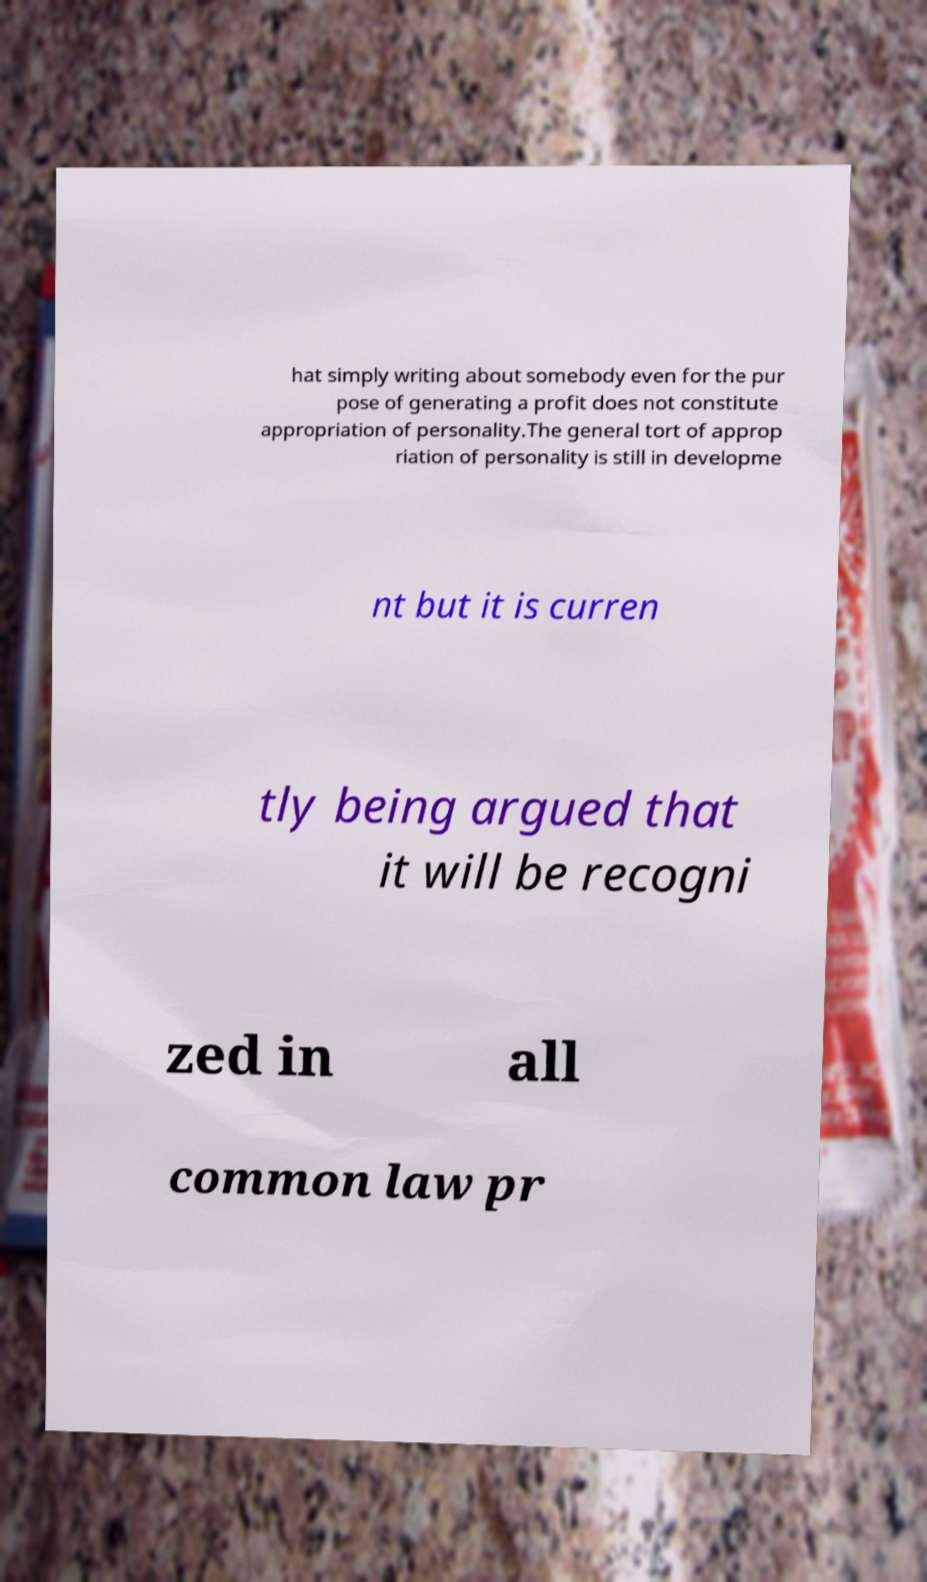Can you accurately transcribe the text from the provided image for me? hat simply writing about somebody even for the pur pose of generating a profit does not constitute appropriation of personality.The general tort of approp riation of personality is still in developme nt but it is curren tly being argued that it will be recogni zed in all common law pr 